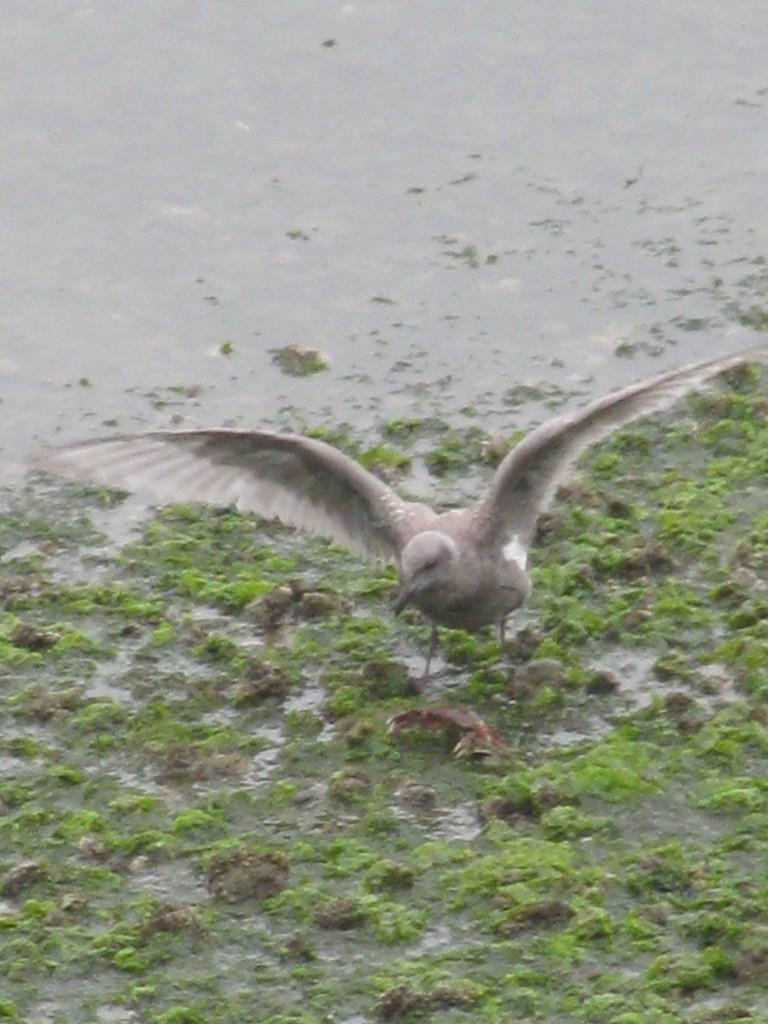What type of animal is in the image? There is a bird in the image. Where is the bird located? The bird is on the water. What else can be seen in the image besides the bird? Stones and water plants are visible in the image. How many eyes does the bird have on its suit in the image? There is no suit present in the image, and birds do not wear suits. Additionally, the number of eyes a bird has is typically two, not dependent on the presence of a suit. 